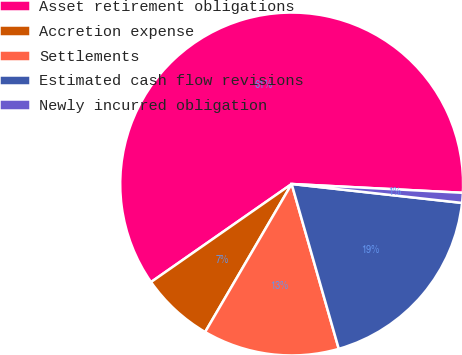Convert chart. <chart><loc_0><loc_0><loc_500><loc_500><pie_chart><fcel>Asset retirement obligations<fcel>Accretion expense<fcel>Settlements<fcel>Estimated cash flow revisions<fcel>Newly incurred obligation<nl><fcel>60.51%<fcel>6.89%<fcel>12.85%<fcel>18.81%<fcel>0.94%<nl></chart> 